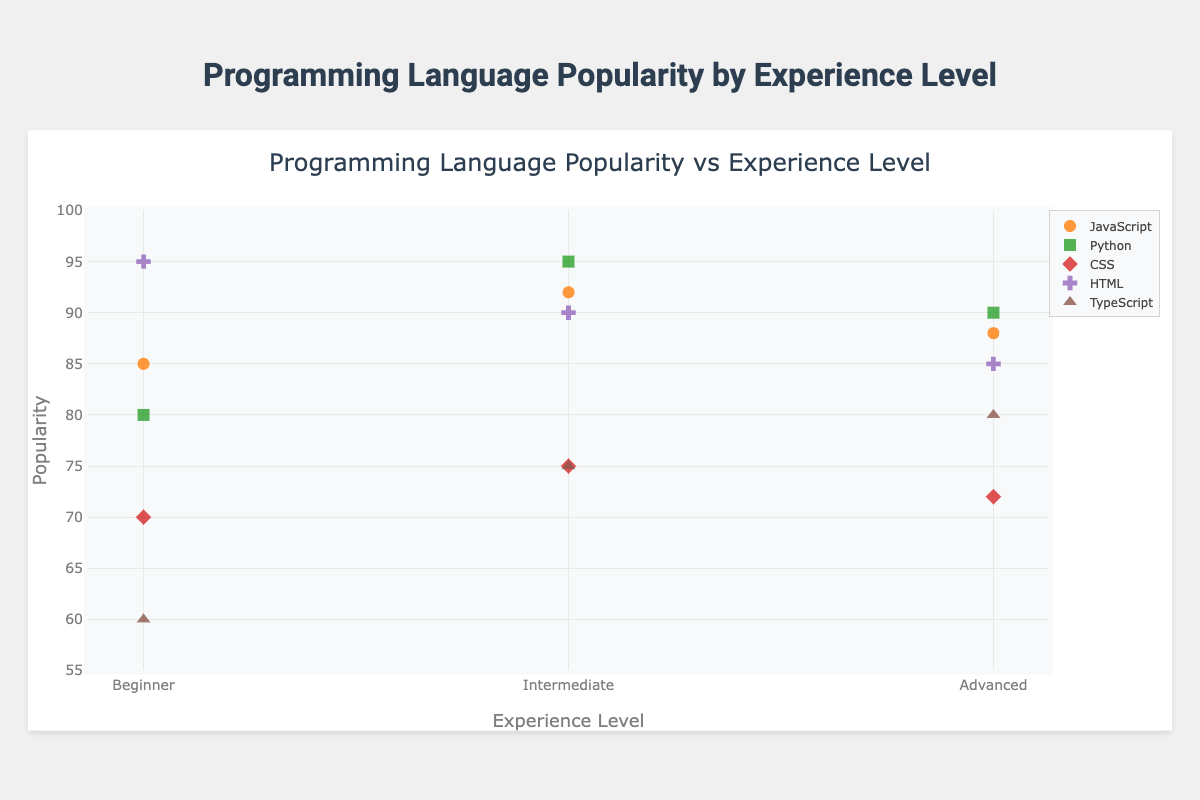What is the title of the chart? The title is displayed at the top of the chart in a larger font compared to the other text elements. In this case, it reads "Programming Language Popularity vs Experience Level."
Answer: Programming Language Popularity vs Experience Level Which programming language shows the highest popularity among beginners? To find this, check the y-axis values for the "Beginner" experience level and determine which language has the highest data point. HTML has a popularity of 95 among beginners, which is the highest.
Answer: HTML How does the popularity of JavaScript change with experience level? Look at the y-axis values for JavaScript data points across all experience levels. For JavaScript, the popularity values are 85 for Beginners, 92 for Intermediate, and 88 for Advanced.
Answer: Increases from Beginner to Intermediate, then decreases for Advanced Compare the popularity of Python and CSS for Advanced users. Which one is higher? Look at the y-axis values for Python and CSS at the "Advanced" experience level. Python has a popularity of 90, while CSS has a popularity of 72. Python is higher.
Answer: Python Which programming language has the lowest popularity among beginners? Check the y-axis values for the "Beginner" experience level and identify the lowest data point. TypeScript has a popularity of 60, which is the lowest.
Answer: TypeScript What is the average popularity of HTML across all experience levels? Sum the popularity values for HTML at all experience levels and divide by the number of levels. The values are 95 (Beginner), 90 (Intermediate), and 85 (Advanced). Average = (95 + 90 + 85) / 3 = 90.
Answer: 90 Which experience level shows the highest popularity for Python? Check the y-axis values for Python at different experience levels. For Python, the values are 80 for Beginners, 95 for Intermediate, and 90 for Advanced. The highest value is at the Intermediate level.
Answer: Intermediate How does the popularity of TypeScript differ between Beginners and Advanced users? Look at the y-axis values for TypeScript for both experience levels. TypeScript has values of 60 for Beginners and 80 for Advanced users. The difference is 80 - 60 = 20.
Answer: 20 Between which two consecutive experience levels does CSS show the most significant change in popularity? Compare the y-axis values for CSS across all experience levels. CSS values are 70 (Beginner), 75 (Intermediate), and 72 (Advanced). The most significant change is between Beginner and Intermediate, with a change of 75 - 70 = 5.
Answer: Beginner to Intermediate Is there any programming language that has a consistent popularity increase with experience level? Check the y-axis trend for each language across all experience levels. None of the programming languages show a consistent increase. Every language has at least one fluctuation in popularity.
Answer: No 